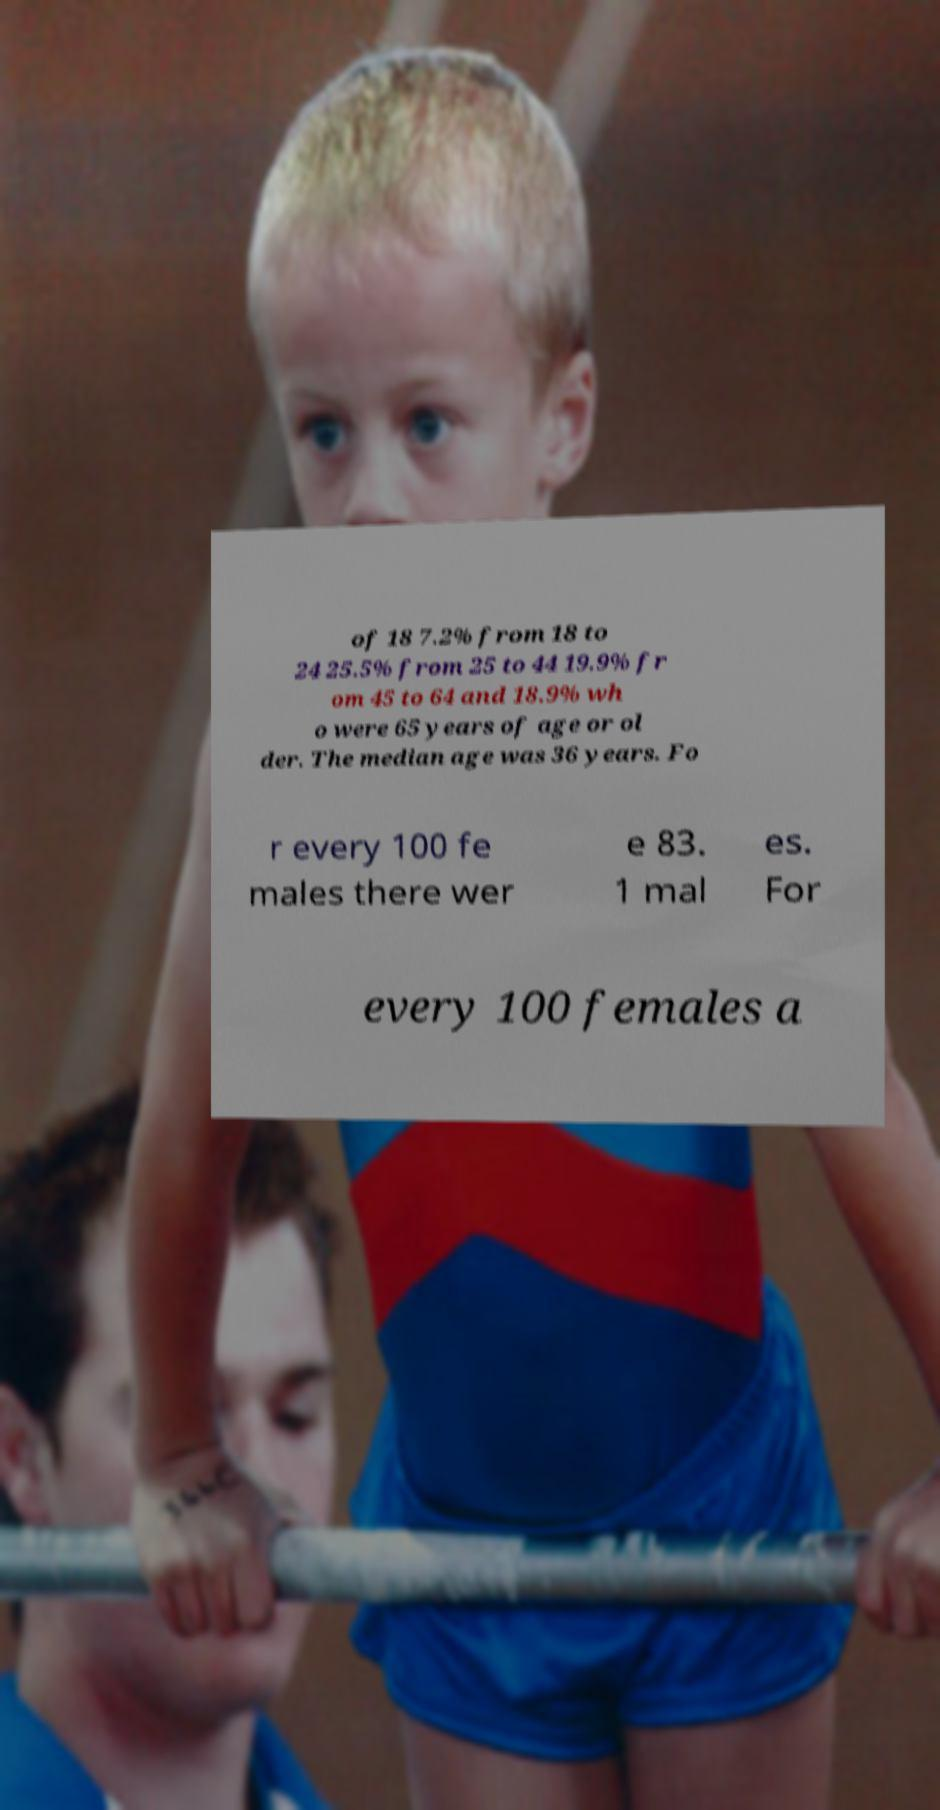I need the written content from this picture converted into text. Can you do that? of 18 7.2% from 18 to 24 25.5% from 25 to 44 19.9% fr om 45 to 64 and 18.9% wh o were 65 years of age or ol der. The median age was 36 years. Fo r every 100 fe males there wer e 83. 1 mal es. For every 100 females a 